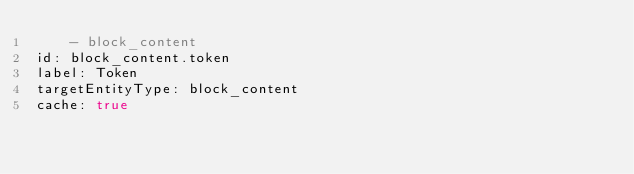Convert code to text. <code><loc_0><loc_0><loc_500><loc_500><_YAML_>    - block_content
id: block_content.token
label: Token
targetEntityType: block_content
cache: true
</code> 